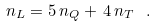Convert formula to latex. <formula><loc_0><loc_0><loc_500><loc_500>n _ { L } = 5 \, n _ { Q } + \, 4 \, n _ { T } \ .</formula> 